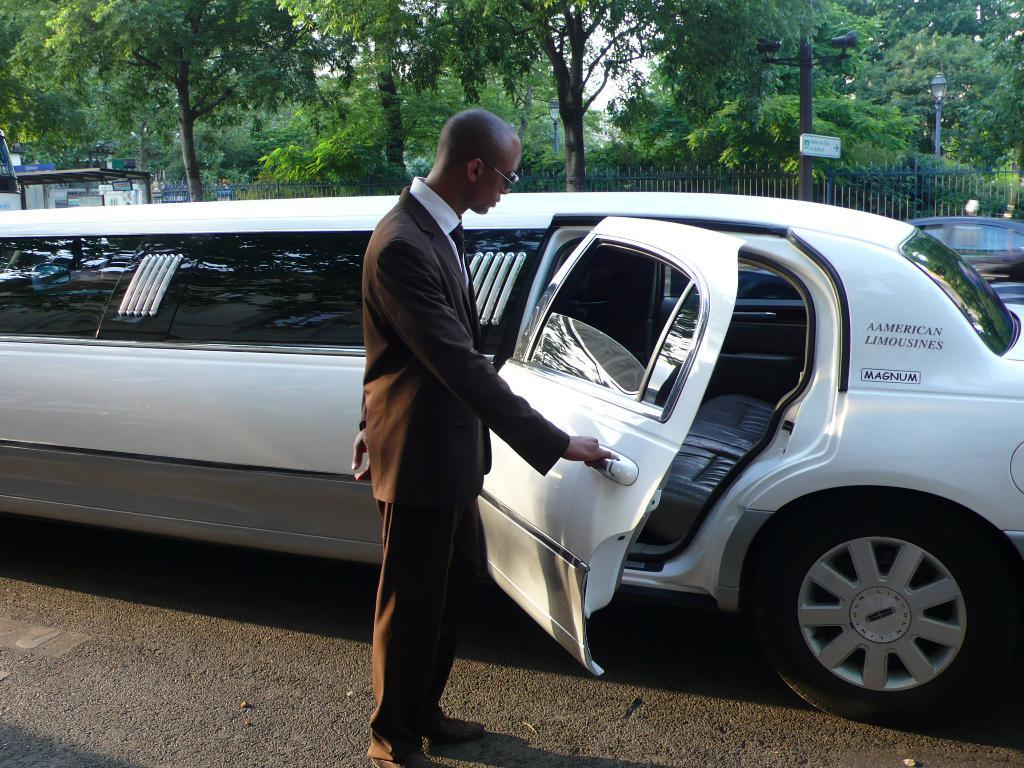Who or what is present in the image? There is a person in the image. What can be seen on the road in the image? There are vehicles on the road in the image. What is visible in the background of the image? There is a fence, trees, poles, and some unspecified objects in the background of the image. What type of bun is being used as a hat by the person in the image? There is no bun present in the image, nor is the person wearing a bun as a hat. 